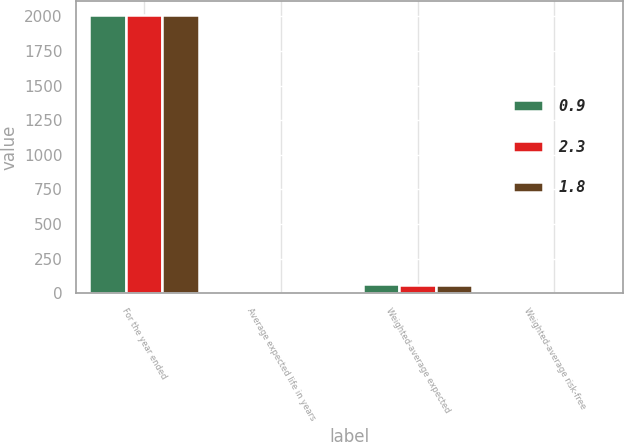Convert chart to OTSL. <chart><loc_0><loc_0><loc_500><loc_500><stacked_bar_chart><ecel><fcel>For the year ended<fcel>Average expected life in years<fcel>Weighted-average expected<fcel>Weighted-average risk-free<nl><fcel>0.9<fcel>2012<fcel>5.1<fcel>66<fcel>0.9<nl><fcel>2.3<fcel>2011<fcel>5.1<fcel>56<fcel>1.8<nl><fcel>1.8<fcel>2010<fcel>5.1<fcel>60<fcel>2.3<nl></chart> 